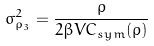Convert formula to latex. <formula><loc_0><loc_0><loc_500><loc_500>\sigma _ { \rho _ { 3 } } ^ { 2 } = \frac { \rho } { 2 \beta V C _ { s y m } ( \rho ) }</formula> 